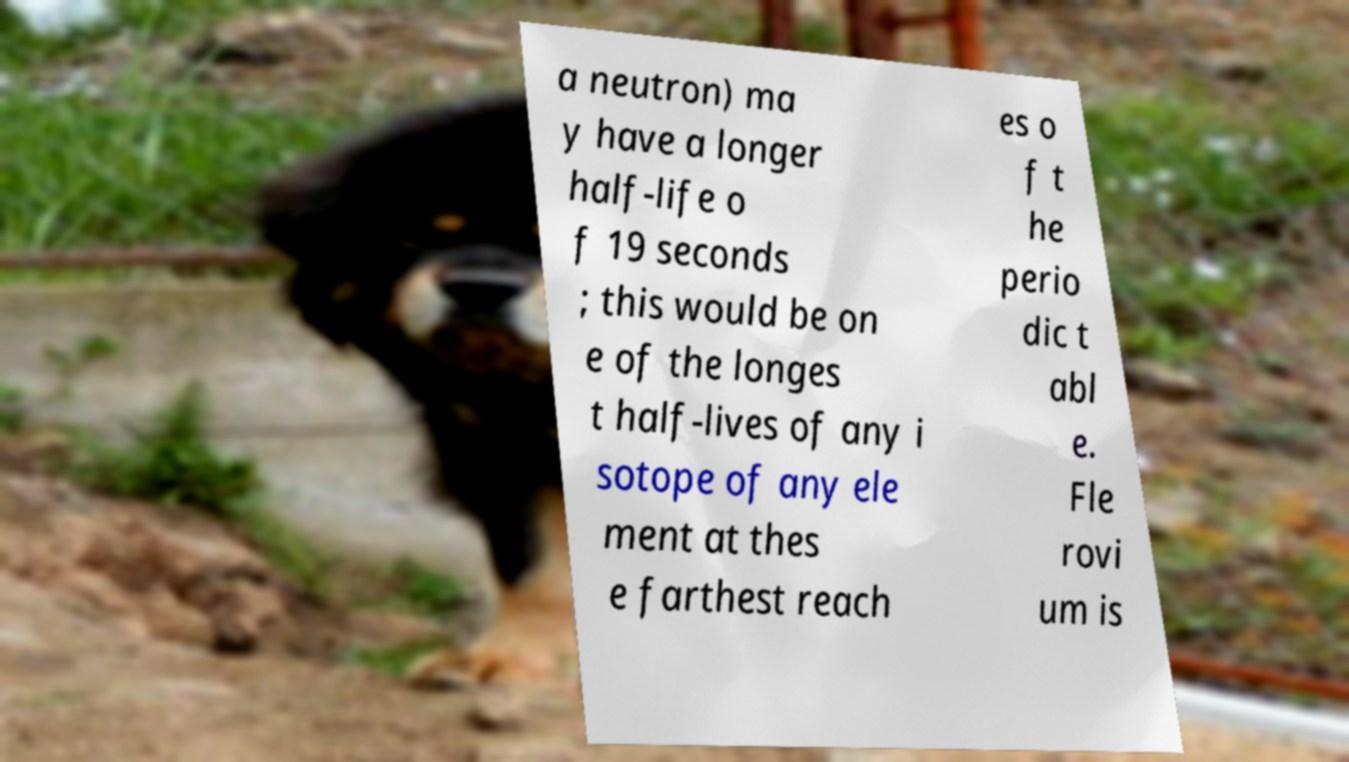There's text embedded in this image that I need extracted. Can you transcribe it verbatim? a neutron) ma y have a longer half-life o f 19 seconds ; this would be on e of the longes t half-lives of any i sotope of any ele ment at thes e farthest reach es o f t he perio dic t abl e. Fle rovi um is 